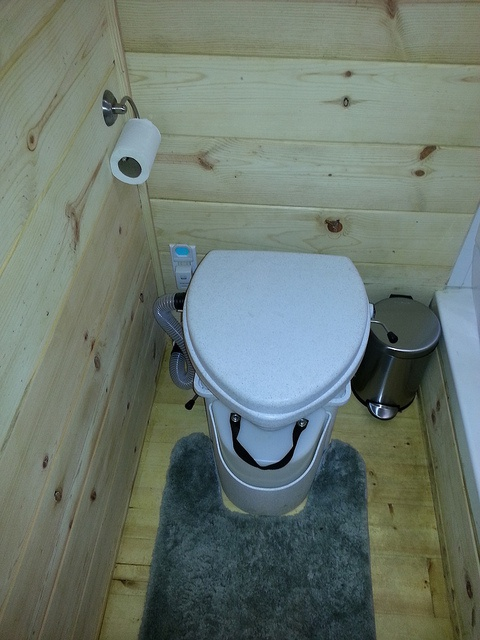Describe the objects in this image and their specific colors. I can see a toilet in gray, lightblue, and darkgray tones in this image. 